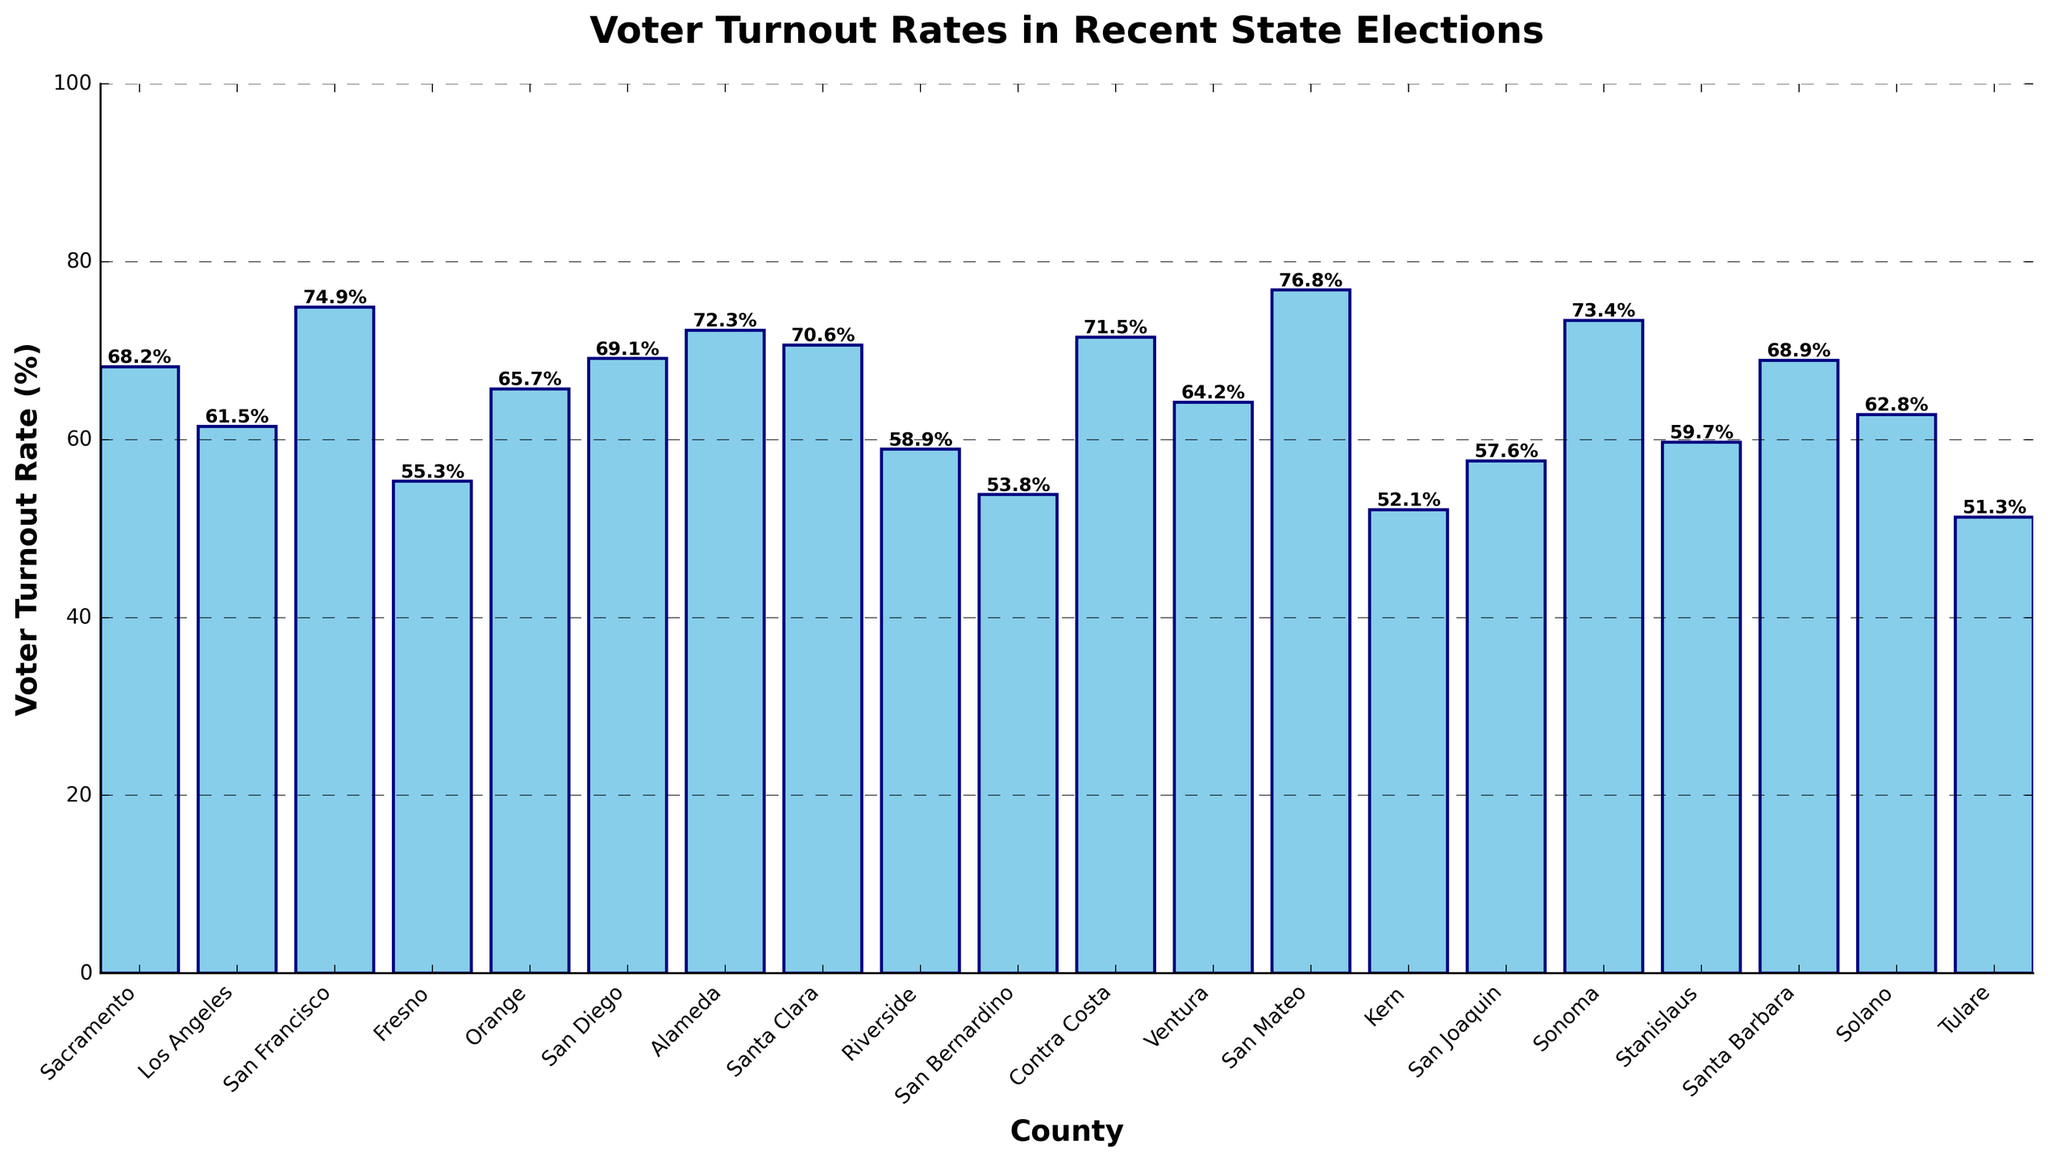Which county has the highest voter turnout rate, and what is the rate? First, scan the bar chart to identify the tallest bar, which visually represents the highest voter turnout rate. Note the county associated with that bar.
Answer: San Mateo, 76.8% Which county has the lowest voter turnout rate, and what is the rate? Identify the shortest bar (the smallest visual height) on the chart to find the lowest voter turnout rate, and note the county it corresponds to.
Answer: Tulare, 51.3% What is the average voter turnout rate across all counties? Sum all the voter turnout rates and then divide by the number of counties. The rates sum to 1297.3 and there are 20 counties, so 1297.3/20.
Answer: 64.865% How much higher is San Francisco's voter turnout rate compared to Los Angeles'? Find the difference between the voter turnout rates of San Francisco (74.9%) and Los Angeles (61.5%) by subtracting the lower rate from the higher rate.
Answer: 13.4% Which counties have a voter turnout rate higher than 70%? Identify the bars that extend above the 70% line on the y-axis and note the counties they correspond to.
Answer: San Francisco, Alameda, Santa Clara, San Mateo, Contra Costa, Sonoma Which two counties have the closest voter turnout rates, and what are those rates? Compare the heights of all bars to find the smallest difference in height, indicating the closest turnout rates.
Answer: Riverside (58.9%) and San Joaquin (57.6%) Is Sacramento's voter turnout rate closer to that of Orange or San Diego? Calculate the difference between Sacramento and each of the other two (Sacramento is 68.2%, Orange is 65.7%, San Diego is 69.1%). The difference with Orange is 2.5% and with San Diego is 0.9%.
Answer: San Diego How much higher is the median voter turnout rate compared to the lowest turnout rate? List all the turnout rates in ascending order to find the median (65.7% as the 10th value in the list). Subtract the lowest rate (51.3%) from the median.
Answer: 14.4% Which counties have a voter turnout rate less than 60% but higher than 50%? Identify the bars that fall within the specified range by examining their heights relative to the y-axis.
Answer: Los Angeles, Fresno, Riverside, San Bernardino, Kern, San Joaquin, Stanislaus, Solano, Tulare What is the total voter turnout rate of the three counties with the highest rates? Identify the three tallest bars (San Mateo, San Francisco, Sonoma) and sum their heights (76.8% + 74.9% + 73.4%).
Answer: 225.1% 